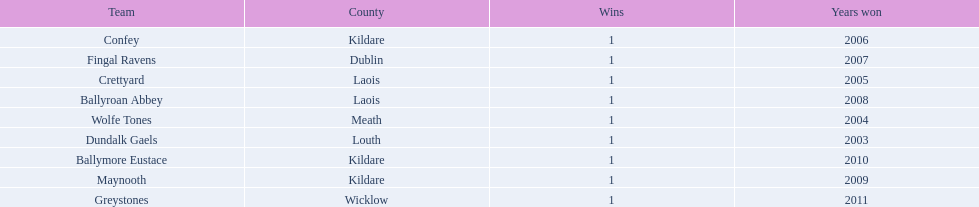What is the number of wins for each team 1. 